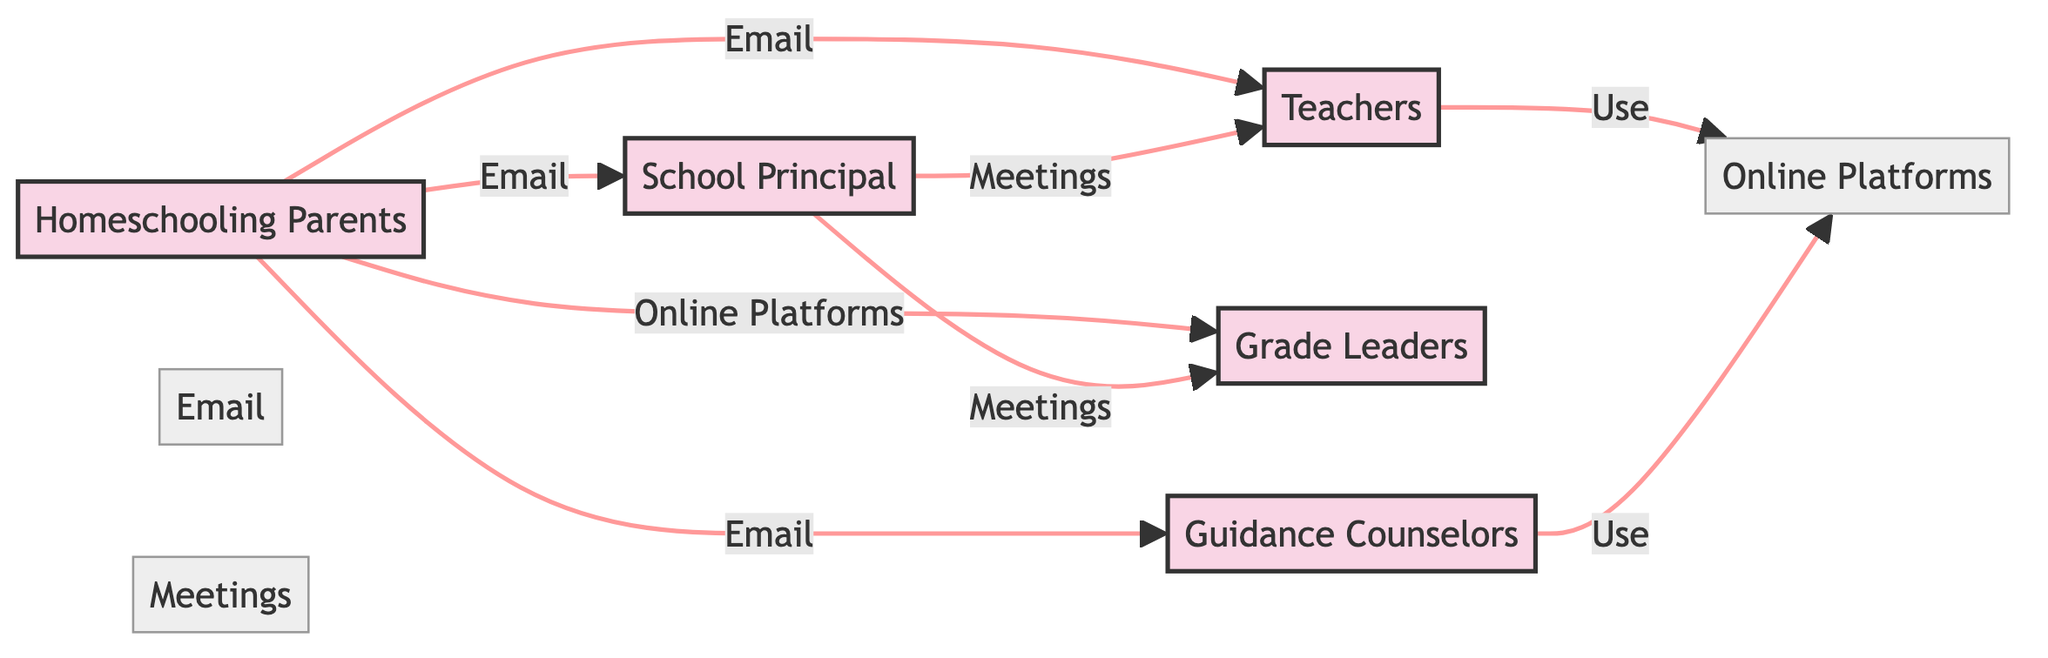What is the total number of nodes in the diagram? The diagram contains nodes for Homeschooling Parents, School Principal, Teachers, Grade Leaders, Guidance Counselors, Email, Online Platforms, and Meetings. Counting these gives us a total of 8 nodes.
Answer: 8 How many edges are outgoing from Homeschooling Parents? Homeschooling Parents has edges directed to School Principal, Teachers, Grade Leaders, and Guidance Counselors. This gives us a total of 4 outgoing edges.
Answer: 4 What channel connects Homeschooling Parents and School Principal? The edge from Homeschooling Parents to School Principal is labeled as Email, indicating that this is the channel used for communication between them.
Answer: Email Which node has the most incoming edges? School Principal has incoming edges from Homeschooling Parents and Teachers, making a total of 3 incoming edges. Thus, School Principal has the most incoming edges in the diagram.
Answer: School Principal What type of communication is used between Teachers and Online Platforms? The edge from Teachers to Online Platforms is labeled as Use, denoting that this is a form of communication or engagement between them via online platforms.
Answer: Use How many types of communication channels are represented in the diagram? The edges showcase three types of channels: Email, Online Platforms, and Meetings. Therefore, there are 3 distinct types of communication channels represented in this diagram.
Answer: 3 What is the relationship between Guidance Counselors and Online Platforms? The edge from Guidance Counselors to Online Platforms indicates a communication channel, specifically stating that Guidance Counselors use Online Platforms to interact or deliver information.
Answer: Use Who communicates with Teachers through Meetings? The diagram shows an edge from School Principal to Teachers that specifies Meetings as the communication channel. Therefore, School Principal communicates with Teachers through Meetings.
Answer: School Principal 